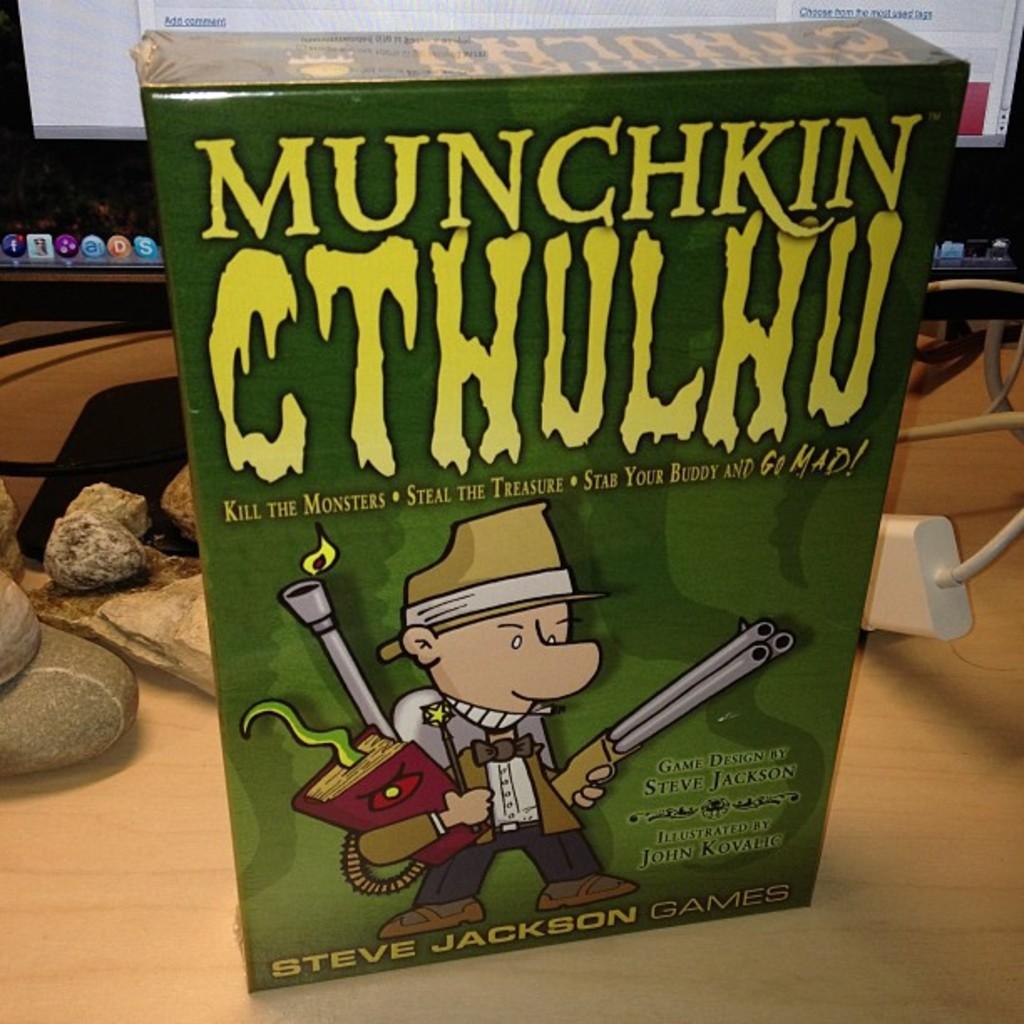What is the title of this game?
Ensure brevity in your answer.  Munchkin cthulhu. 